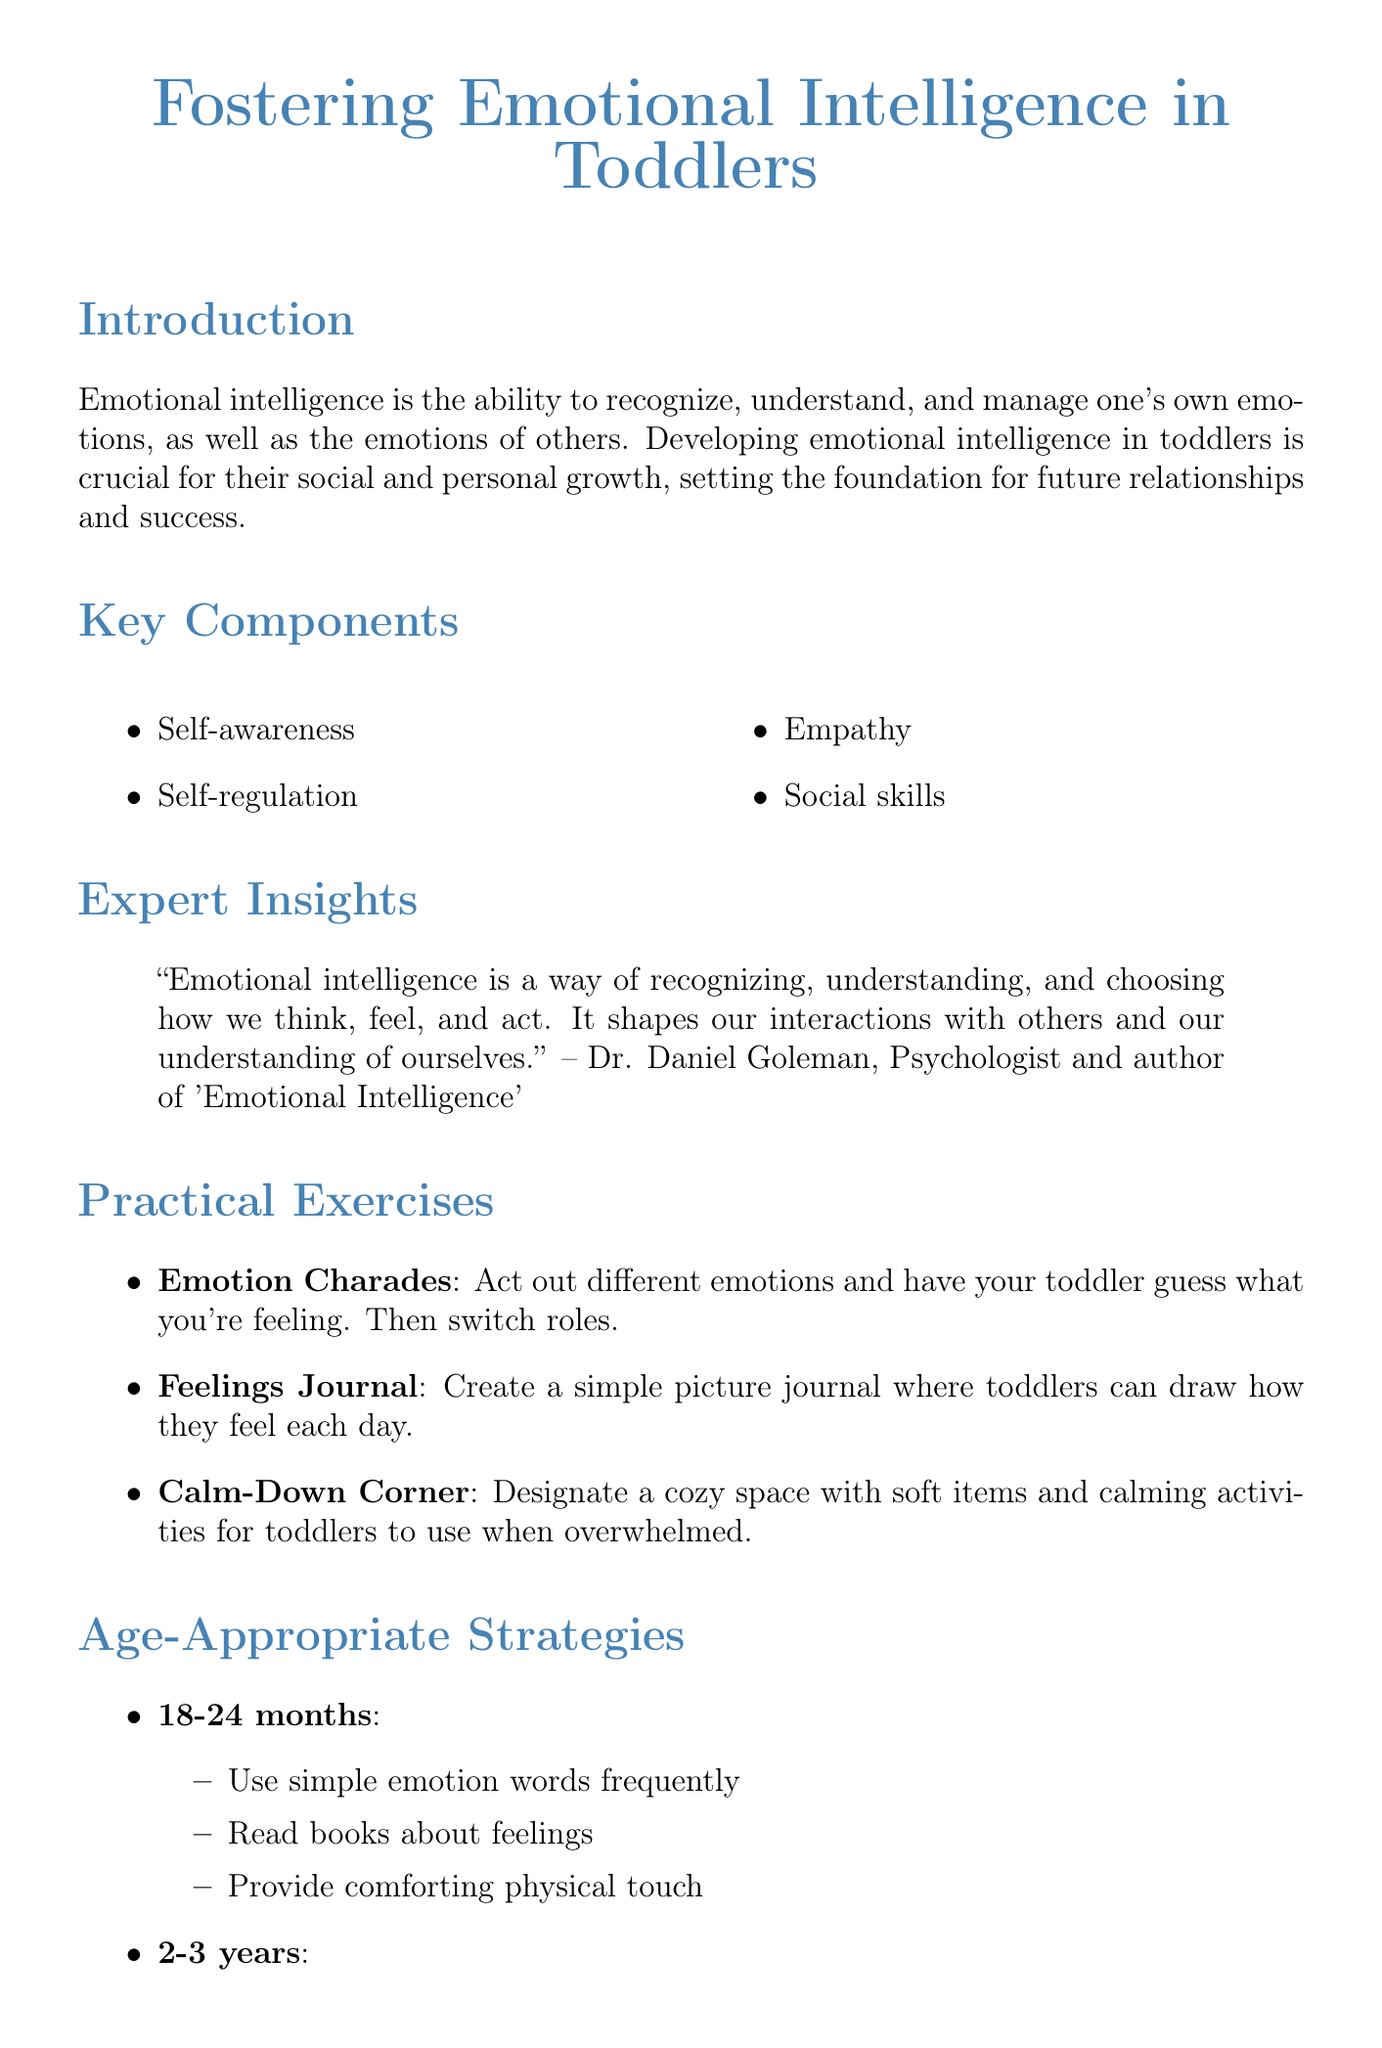What is the chapter title? The chapter title is presented at the beginning of the document, labeling the focus on emotional intelligence for young children.
Answer: Fostering Emotional Intelligence in Toddlers What are the key components of emotional intelligence listed? The key components are mentioned in their own section, highlighting the main skills to develop.
Answer: Self-awareness, Self-regulation, Empathy, Social skills Who is the author of the quote about recognizing and understanding emotions? This information is found in the expert quotes section, identifying a source of authority on the topic.
Answer: Dr. Daniel Goleman What is one practical exercise mentioned that helps toddlers recognize emotions? This exercise is part of the practical exercises section, encouraging interaction and recognition of feelings.
Answer: Emotion Charades What age group's strategies include providing comforting physical touch? The document specifies strategies by age group, pointing to specific developmental appropriateness.
Answer: 18-24 months What common challenge is associated with temper tantrums? The document explicitly discusses challenges and corresponding solutions for parents.
Answer: Acknowledge feelings What is the title of a resource mentioned for parents? The resources section lists helpful materials, supporting further learning.
Answer: The Whole-Brain Child How many practical exercises are provided in the document? This information can be determined by counting the exercises listed in the relevant section.
Answer: Three 